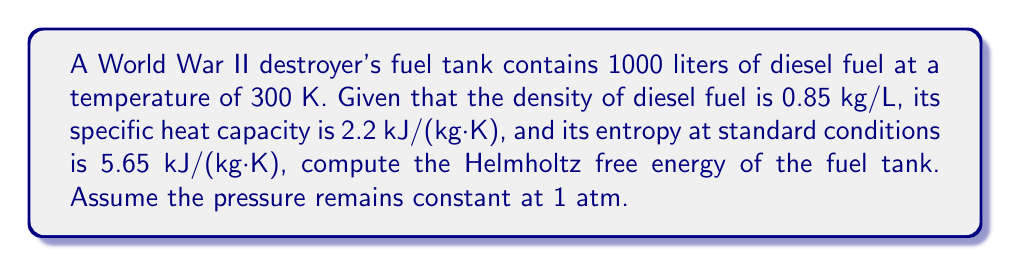Can you solve this math problem? To calculate the Helmholtz free energy (F), we use the formula:

$$F = U - TS$$

Where:
U = Internal energy
T = Temperature
S = Entropy

Step 1: Calculate the mass of the fuel
$$m = \text{Volume} \times \text{Density} = 1000 \text{ L} \times 0.85 \text{ kg/L} = 850 \text{ kg}$$

Step 2: Calculate the internal energy (U)
For liquids, we can approximate U as:
$$U \approx m \times c \times T$$
Where c is the specific heat capacity

$$U = 850 \text{ kg} \times 2.2 \text{ kJ/(kg·K)} \times 300 \text{ K} = 561,000 \text{ kJ}$$

Step 3: Calculate the total entropy (S)
$$S = m \times s = 850 \text{ kg} \times 5.65 \text{ kJ/(kg·K)} = 4,802.5 \text{ kJ/K}$$

Step 4: Calculate the Helmholtz free energy
$$F = U - TS = 561,000 \text{ kJ} - (300 \text{ K} \times 4,802.5 \text{ kJ/K})$$
$$F = 561,000 \text{ kJ} - 1,440,750 \text{ kJ} = -879,750 \text{ kJ}$$
Answer: $-879,750 \text{ kJ}$ 